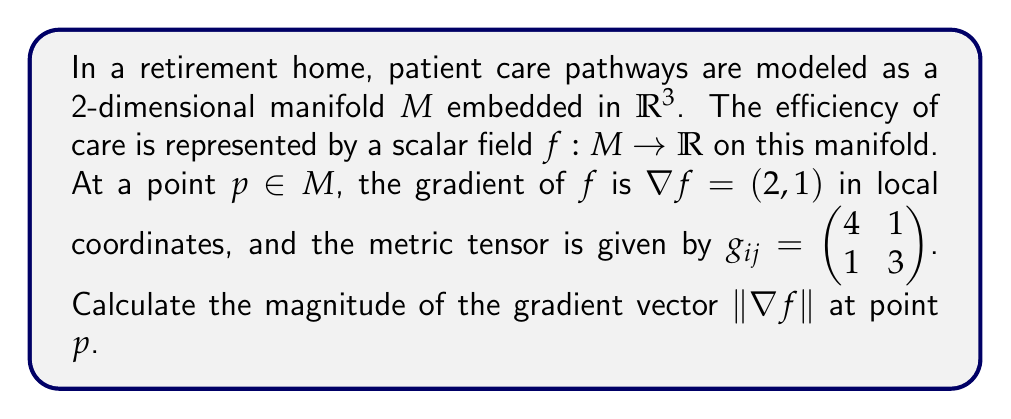Provide a solution to this math problem. To solve this problem, we need to understand the relationship between the gradient and the metric tensor on a manifold. The steps to calculate the magnitude of the gradient vector are as follows:

1) On a Riemannian manifold, the magnitude of a vector is calculated using the metric tensor. For a vector $v$ with components $v^i$ in local coordinates, the squared magnitude is given by:

   $$\|v\|^2 = g_{ij}v^iv^j$$

   where $g_{ij}$ are the components of the metric tensor, and we use the Einstein summation convention.

2) In our case, the vector is the gradient $\nabla f = (2, 1)$, so $v^1 = 2$ and $v^2 = 1$.

3) The metric tensor is given as $g_{ij} = \begin{pmatrix} 4 & 1 \\ 1 & 3 \end{pmatrix}$.

4) Let's calculate each term of $g_{ij}v^iv^j$:
   
   $g_{11}v^1v^1 = 4 \cdot 2 \cdot 2 = 16$
   $g_{12}v^1v^2 = 1 \cdot 2 \cdot 1 = 2$
   $g_{21}v^2v^1 = 1 \cdot 1 \cdot 2 = 2$
   $g_{22}v^2v^2 = 3 \cdot 1 \cdot 1 = 3$

5) Sum these terms:

   $$\|\nabla f\|^2 = 16 + 2 + 2 + 3 = 23$$

6) Take the square root to get the magnitude:

   $$\|\nabla f\| = \sqrt{23}$$
Answer: $\sqrt{23}$ 